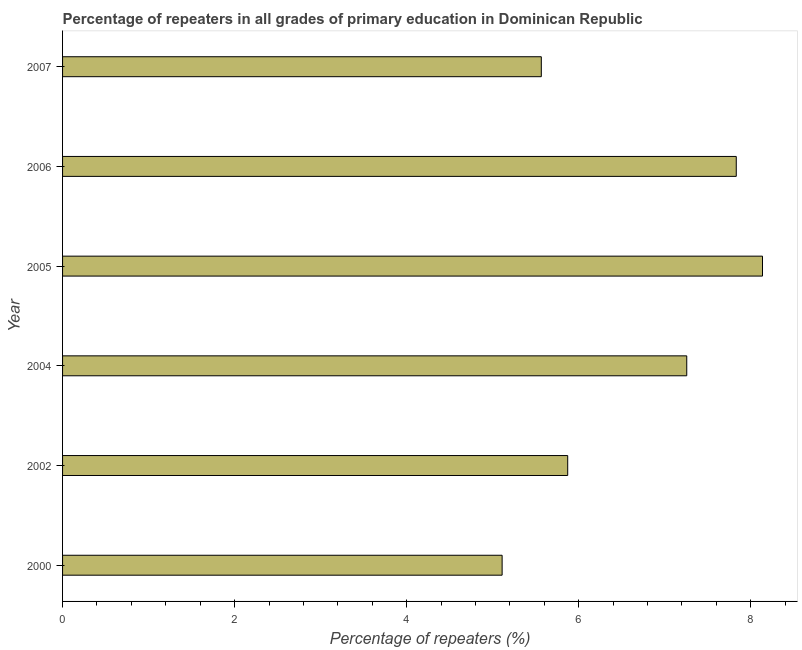Does the graph contain any zero values?
Keep it short and to the point. No. Does the graph contain grids?
Provide a succinct answer. No. What is the title of the graph?
Your answer should be compact. Percentage of repeaters in all grades of primary education in Dominican Republic. What is the label or title of the X-axis?
Provide a succinct answer. Percentage of repeaters (%). What is the label or title of the Y-axis?
Offer a terse response. Year. What is the percentage of repeaters in primary education in 2004?
Make the answer very short. 7.26. Across all years, what is the maximum percentage of repeaters in primary education?
Your answer should be compact. 8.14. Across all years, what is the minimum percentage of repeaters in primary education?
Provide a succinct answer. 5.11. In which year was the percentage of repeaters in primary education maximum?
Give a very brief answer. 2005. In which year was the percentage of repeaters in primary education minimum?
Ensure brevity in your answer.  2000. What is the sum of the percentage of repeaters in primary education?
Give a very brief answer. 39.77. What is the difference between the percentage of repeaters in primary education in 2002 and 2007?
Your answer should be very brief. 0.31. What is the average percentage of repeaters in primary education per year?
Your answer should be compact. 6.63. What is the median percentage of repeaters in primary education?
Your response must be concise. 6.56. In how many years, is the percentage of repeaters in primary education greater than 5.6 %?
Offer a very short reply. 4. What is the ratio of the percentage of repeaters in primary education in 2004 to that in 2006?
Your response must be concise. 0.93. Is the percentage of repeaters in primary education in 2002 less than that in 2005?
Give a very brief answer. Yes. Is the difference between the percentage of repeaters in primary education in 2004 and 2006 greater than the difference between any two years?
Provide a succinct answer. No. What is the difference between the highest and the second highest percentage of repeaters in primary education?
Your answer should be compact. 0.3. What is the difference between the highest and the lowest percentage of repeaters in primary education?
Provide a short and direct response. 3.03. How many bars are there?
Your response must be concise. 6. Are all the bars in the graph horizontal?
Keep it short and to the point. Yes. How many years are there in the graph?
Provide a succinct answer. 6. What is the difference between two consecutive major ticks on the X-axis?
Offer a terse response. 2. Are the values on the major ticks of X-axis written in scientific E-notation?
Give a very brief answer. No. What is the Percentage of repeaters (%) of 2000?
Provide a short and direct response. 5.11. What is the Percentage of repeaters (%) in 2002?
Make the answer very short. 5.87. What is the Percentage of repeaters (%) in 2004?
Keep it short and to the point. 7.26. What is the Percentage of repeaters (%) in 2005?
Offer a terse response. 8.14. What is the Percentage of repeaters (%) of 2006?
Make the answer very short. 7.83. What is the Percentage of repeaters (%) of 2007?
Your answer should be compact. 5.57. What is the difference between the Percentage of repeaters (%) in 2000 and 2002?
Offer a very short reply. -0.76. What is the difference between the Percentage of repeaters (%) in 2000 and 2004?
Provide a succinct answer. -2.15. What is the difference between the Percentage of repeaters (%) in 2000 and 2005?
Your answer should be very brief. -3.03. What is the difference between the Percentage of repeaters (%) in 2000 and 2006?
Your response must be concise. -2.72. What is the difference between the Percentage of repeaters (%) in 2000 and 2007?
Your answer should be compact. -0.46. What is the difference between the Percentage of repeaters (%) in 2002 and 2004?
Ensure brevity in your answer.  -1.38. What is the difference between the Percentage of repeaters (%) in 2002 and 2005?
Your response must be concise. -2.26. What is the difference between the Percentage of repeaters (%) in 2002 and 2006?
Give a very brief answer. -1.96. What is the difference between the Percentage of repeaters (%) in 2002 and 2007?
Give a very brief answer. 0.31. What is the difference between the Percentage of repeaters (%) in 2004 and 2005?
Give a very brief answer. -0.88. What is the difference between the Percentage of repeaters (%) in 2004 and 2006?
Offer a terse response. -0.58. What is the difference between the Percentage of repeaters (%) in 2004 and 2007?
Provide a short and direct response. 1.69. What is the difference between the Percentage of repeaters (%) in 2005 and 2006?
Ensure brevity in your answer.  0.3. What is the difference between the Percentage of repeaters (%) in 2005 and 2007?
Give a very brief answer. 2.57. What is the difference between the Percentage of repeaters (%) in 2006 and 2007?
Offer a terse response. 2.27. What is the ratio of the Percentage of repeaters (%) in 2000 to that in 2002?
Ensure brevity in your answer.  0.87. What is the ratio of the Percentage of repeaters (%) in 2000 to that in 2004?
Your answer should be very brief. 0.7. What is the ratio of the Percentage of repeaters (%) in 2000 to that in 2005?
Make the answer very short. 0.63. What is the ratio of the Percentage of repeaters (%) in 2000 to that in 2006?
Keep it short and to the point. 0.65. What is the ratio of the Percentage of repeaters (%) in 2000 to that in 2007?
Keep it short and to the point. 0.92. What is the ratio of the Percentage of repeaters (%) in 2002 to that in 2004?
Your answer should be very brief. 0.81. What is the ratio of the Percentage of repeaters (%) in 2002 to that in 2005?
Ensure brevity in your answer.  0.72. What is the ratio of the Percentage of repeaters (%) in 2002 to that in 2006?
Your answer should be compact. 0.75. What is the ratio of the Percentage of repeaters (%) in 2002 to that in 2007?
Provide a succinct answer. 1.05. What is the ratio of the Percentage of repeaters (%) in 2004 to that in 2005?
Your answer should be very brief. 0.89. What is the ratio of the Percentage of repeaters (%) in 2004 to that in 2006?
Your response must be concise. 0.93. What is the ratio of the Percentage of repeaters (%) in 2004 to that in 2007?
Your response must be concise. 1.3. What is the ratio of the Percentage of repeaters (%) in 2005 to that in 2006?
Offer a very short reply. 1.04. What is the ratio of the Percentage of repeaters (%) in 2005 to that in 2007?
Ensure brevity in your answer.  1.46. What is the ratio of the Percentage of repeaters (%) in 2006 to that in 2007?
Keep it short and to the point. 1.41. 